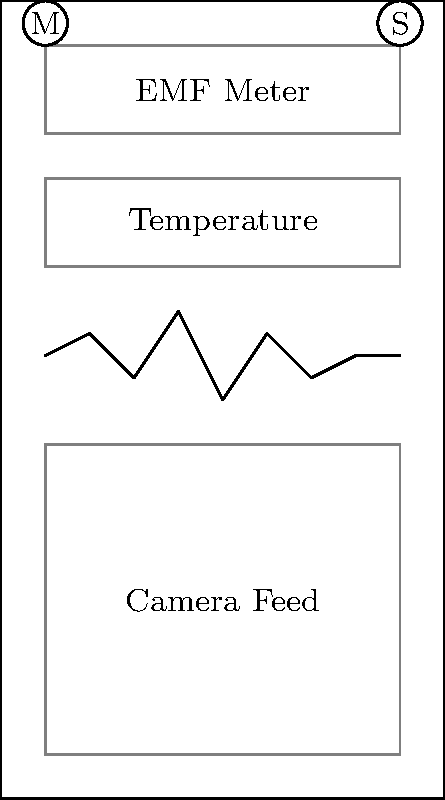In designing a user interface for a ghost hunting app, which layout principle is most crucial for effectively presenting real-time data from multiple sensors (EMF, temperature, audio, and camera) while ensuring user-friendly navigation? To design an effective user interface for a ghost hunting app with multiple sensor inputs and real-time data display, we need to consider several key principles:

1. Information Hierarchy: The most critical data should be prominently displayed. In this case, the EMF meter and temperature readings are placed at the top of the screen for quick access.

2. Visual Clarity: Each data input is clearly separated and labeled to avoid confusion. The camera feed, being the largest element, is placed at the bottom to provide visual context.

3. Real-time Updates: The audio waveform is displayed as a continuously updating graph, allowing for immediate recognition of audio anomalies.

4. Accessibility: Menu and settings buttons are placed in the top corners for easy access without obstructing the main content.

5. Scalability: The layout allows for additional sensors or features to be added without major redesign.

However, the most crucial principle in this context is Progressive Disclosure. This principle suggests that information should be revealed progressively, showing only what is necessary at each point in the user's journey. In a ghost hunting app, where users need to quickly interpret data from multiple sources in potentially stressful situations, it's vital to present information in a way that doesn't overwhelm the user.

The layout shown progressively discloses information by:
a) Displaying summary data (EMF and temperature) prominently
b) Showing real-time audio data in a compact, easily interpretable format
c) Providing a larger area for visual data (camera feed) which can be expanded if needed
d) Hiding advanced features behind menu and settings buttons

This approach allows users to focus on the most relevant data while still having access to all features, making it ideal for real-time paranormal investigation scenarios.
Answer: Progressive Disclosure 